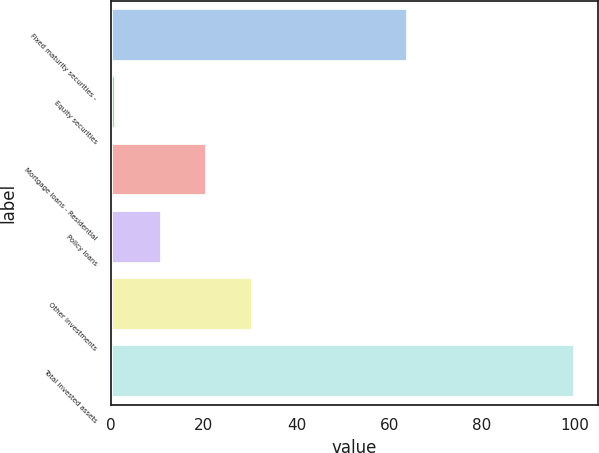Convert chart to OTSL. <chart><loc_0><loc_0><loc_500><loc_500><bar_chart><fcel>Fixed maturity securities -<fcel>Equity securities<fcel>Mortgage loans - Residential<fcel>Policy loans<fcel>Other investments<fcel>Total invested assets<nl><fcel>64<fcel>1<fcel>20.8<fcel>10.9<fcel>30.7<fcel>100<nl></chart> 